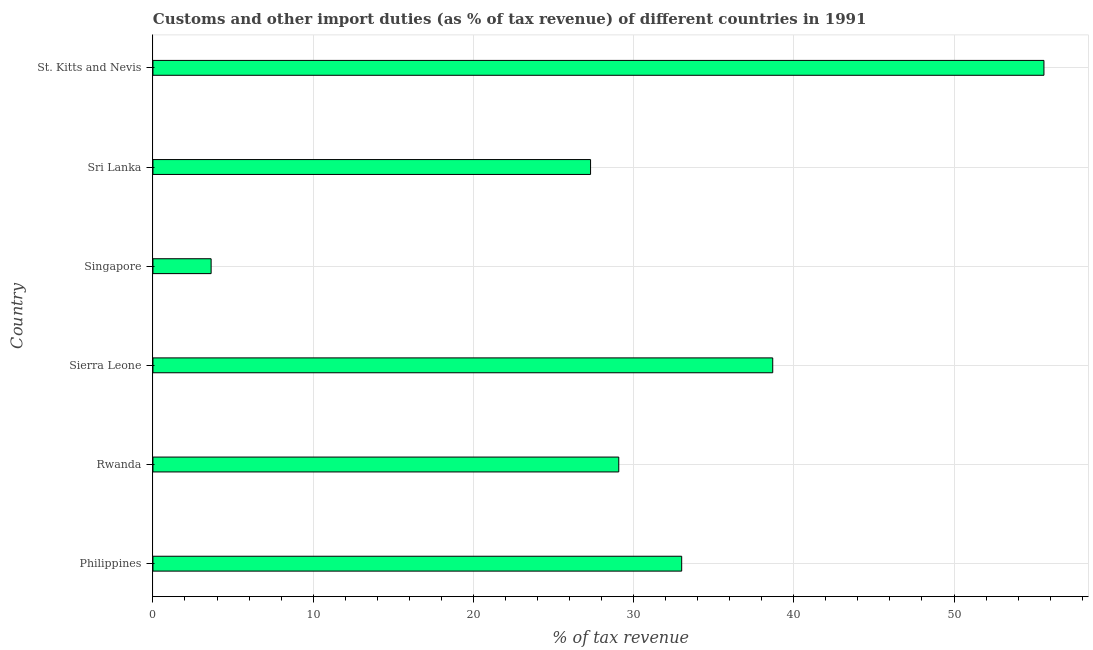What is the title of the graph?
Offer a terse response. Customs and other import duties (as % of tax revenue) of different countries in 1991. What is the label or title of the X-axis?
Offer a terse response. % of tax revenue. What is the label or title of the Y-axis?
Your answer should be very brief. Country. What is the customs and other import duties in Philippines?
Your answer should be very brief. 33. Across all countries, what is the maximum customs and other import duties?
Your response must be concise. 55.61. Across all countries, what is the minimum customs and other import duties?
Your response must be concise. 3.63. In which country was the customs and other import duties maximum?
Your answer should be very brief. St. Kitts and Nevis. In which country was the customs and other import duties minimum?
Keep it short and to the point. Singapore. What is the sum of the customs and other import duties?
Give a very brief answer. 187.32. What is the difference between the customs and other import duties in Philippines and St. Kitts and Nevis?
Provide a short and direct response. -22.61. What is the average customs and other import duties per country?
Your answer should be compact. 31.22. What is the median customs and other import duties?
Keep it short and to the point. 31.04. In how many countries, is the customs and other import duties greater than 30 %?
Ensure brevity in your answer.  3. What is the ratio of the customs and other import duties in Rwanda to that in St. Kitts and Nevis?
Keep it short and to the point. 0.52. What is the difference between the highest and the second highest customs and other import duties?
Offer a terse response. 16.93. Is the sum of the customs and other import duties in Rwanda and Sierra Leone greater than the maximum customs and other import duties across all countries?
Provide a short and direct response. Yes. What is the difference between the highest and the lowest customs and other import duties?
Your response must be concise. 51.98. How many bars are there?
Your answer should be compact. 6. Are all the bars in the graph horizontal?
Offer a terse response. Yes. Are the values on the major ticks of X-axis written in scientific E-notation?
Give a very brief answer. No. What is the % of tax revenue in Philippines?
Keep it short and to the point. 33. What is the % of tax revenue of Rwanda?
Provide a succinct answer. 29.08. What is the % of tax revenue of Sierra Leone?
Ensure brevity in your answer.  38.69. What is the % of tax revenue of Singapore?
Provide a short and direct response. 3.63. What is the % of tax revenue in Sri Lanka?
Your answer should be very brief. 27.31. What is the % of tax revenue in St. Kitts and Nevis?
Make the answer very short. 55.61. What is the difference between the % of tax revenue in Philippines and Rwanda?
Offer a very short reply. 3.93. What is the difference between the % of tax revenue in Philippines and Sierra Leone?
Ensure brevity in your answer.  -5.68. What is the difference between the % of tax revenue in Philippines and Singapore?
Give a very brief answer. 29.37. What is the difference between the % of tax revenue in Philippines and Sri Lanka?
Offer a terse response. 5.69. What is the difference between the % of tax revenue in Philippines and St. Kitts and Nevis?
Your answer should be very brief. -22.61. What is the difference between the % of tax revenue in Rwanda and Sierra Leone?
Make the answer very short. -9.61. What is the difference between the % of tax revenue in Rwanda and Singapore?
Your answer should be compact. 25.44. What is the difference between the % of tax revenue in Rwanda and Sri Lanka?
Ensure brevity in your answer.  1.76. What is the difference between the % of tax revenue in Rwanda and St. Kitts and Nevis?
Make the answer very short. -26.54. What is the difference between the % of tax revenue in Sierra Leone and Singapore?
Your answer should be very brief. 35.05. What is the difference between the % of tax revenue in Sierra Leone and Sri Lanka?
Ensure brevity in your answer.  11.37. What is the difference between the % of tax revenue in Sierra Leone and St. Kitts and Nevis?
Offer a very short reply. -16.93. What is the difference between the % of tax revenue in Singapore and Sri Lanka?
Ensure brevity in your answer.  -23.68. What is the difference between the % of tax revenue in Singapore and St. Kitts and Nevis?
Offer a very short reply. -51.98. What is the difference between the % of tax revenue in Sri Lanka and St. Kitts and Nevis?
Provide a succinct answer. -28.3. What is the ratio of the % of tax revenue in Philippines to that in Rwanda?
Give a very brief answer. 1.14. What is the ratio of the % of tax revenue in Philippines to that in Sierra Leone?
Offer a very short reply. 0.85. What is the ratio of the % of tax revenue in Philippines to that in Singapore?
Provide a short and direct response. 9.09. What is the ratio of the % of tax revenue in Philippines to that in Sri Lanka?
Provide a short and direct response. 1.21. What is the ratio of the % of tax revenue in Philippines to that in St. Kitts and Nevis?
Provide a succinct answer. 0.59. What is the ratio of the % of tax revenue in Rwanda to that in Sierra Leone?
Make the answer very short. 0.75. What is the ratio of the % of tax revenue in Rwanda to that in Singapore?
Make the answer very short. 8.01. What is the ratio of the % of tax revenue in Rwanda to that in Sri Lanka?
Make the answer very short. 1.06. What is the ratio of the % of tax revenue in Rwanda to that in St. Kitts and Nevis?
Provide a short and direct response. 0.52. What is the ratio of the % of tax revenue in Sierra Leone to that in Singapore?
Your answer should be very brief. 10.65. What is the ratio of the % of tax revenue in Sierra Leone to that in Sri Lanka?
Offer a very short reply. 1.42. What is the ratio of the % of tax revenue in Sierra Leone to that in St. Kitts and Nevis?
Keep it short and to the point. 0.7. What is the ratio of the % of tax revenue in Singapore to that in Sri Lanka?
Make the answer very short. 0.13. What is the ratio of the % of tax revenue in Singapore to that in St. Kitts and Nevis?
Your response must be concise. 0.07. What is the ratio of the % of tax revenue in Sri Lanka to that in St. Kitts and Nevis?
Your response must be concise. 0.49. 